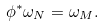Convert formula to latex. <formula><loc_0><loc_0><loc_500><loc_500>\phi ^ { * } \omega _ { N } = \omega _ { M } .</formula> 